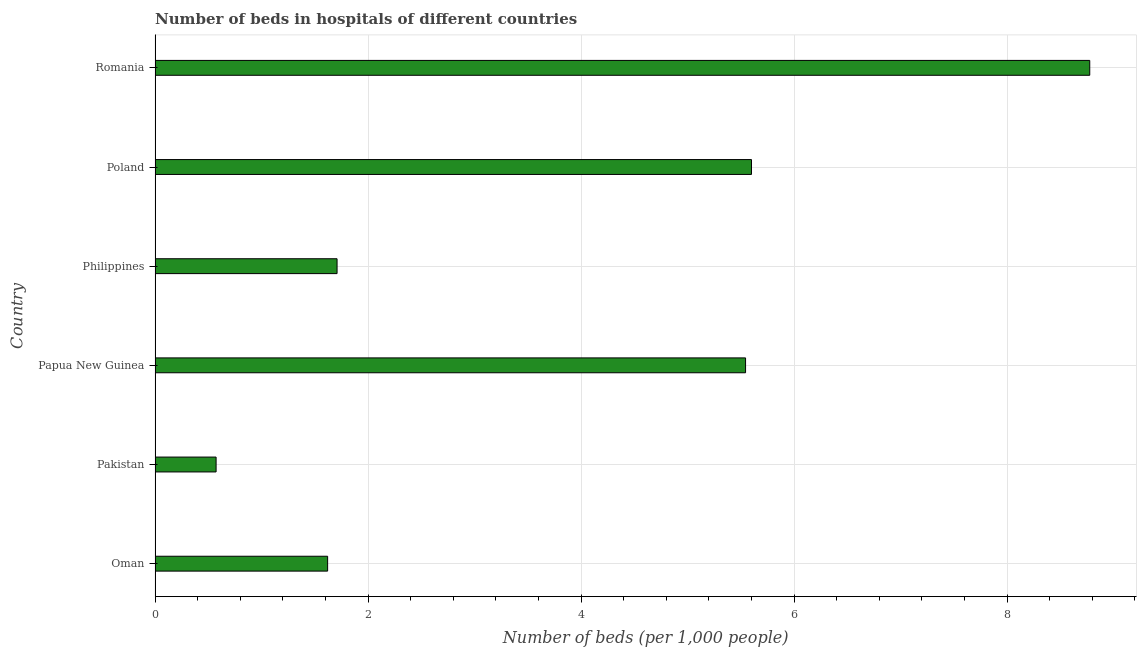Does the graph contain any zero values?
Provide a short and direct response. No. What is the title of the graph?
Provide a succinct answer. Number of beds in hospitals of different countries. What is the label or title of the X-axis?
Keep it short and to the point. Number of beds (per 1,0 people). What is the number of hospital beds in Pakistan?
Provide a succinct answer. 0.57. Across all countries, what is the maximum number of hospital beds?
Your answer should be compact. 8.78. Across all countries, what is the minimum number of hospital beds?
Offer a terse response. 0.57. In which country was the number of hospital beds maximum?
Provide a succinct answer. Romania. What is the sum of the number of hospital beds?
Provide a short and direct response. 23.82. What is the difference between the number of hospital beds in Pakistan and Philippines?
Keep it short and to the point. -1.14. What is the average number of hospital beds per country?
Offer a very short reply. 3.97. What is the median number of hospital beds?
Your response must be concise. 3.63. What is the ratio of the number of hospital beds in Pakistan to that in Romania?
Your response must be concise. 0.07. Is the difference between the number of hospital beds in Papua New Guinea and Poland greater than the difference between any two countries?
Offer a terse response. No. What is the difference between the highest and the second highest number of hospital beds?
Provide a succinct answer. 3.18. Is the sum of the number of hospital beds in Papua New Guinea and Philippines greater than the maximum number of hospital beds across all countries?
Make the answer very short. No. How many bars are there?
Provide a short and direct response. 6. How many countries are there in the graph?
Offer a very short reply. 6. What is the difference between two consecutive major ticks on the X-axis?
Your answer should be compact. 2. What is the Number of beds (per 1,000 people) in Oman?
Provide a succinct answer. 1.62. What is the Number of beds (per 1,000 people) in Pakistan?
Your response must be concise. 0.57. What is the Number of beds (per 1,000 people) of Papua New Guinea?
Make the answer very short. 5.54. What is the Number of beds (per 1,000 people) in Philippines?
Provide a short and direct response. 1.71. What is the Number of beds (per 1,000 people) in Poland?
Give a very brief answer. 5.6. What is the Number of beds (per 1,000 people) in Romania?
Keep it short and to the point. 8.78. What is the difference between the Number of beds (per 1,000 people) in Oman and Pakistan?
Your response must be concise. 1.05. What is the difference between the Number of beds (per 1,000 people) in Oman and Papua New Guinea?
Give a very brief answer. -3.92. What is the difference between the Number of beds (per 1,000 people) in Oman and Philippines?
Ensure brevity in your answer.  -0.09. What is the difference between the Number of beds (per 1,000 people) in Oman and Poland?
Provide a succinct answer. -3.98. What is the difference between the Number of beds (per 1,000 people) in Oman and Romania?
Offer a very short reply. -7.16. What is the difference between the Number of beds (per 1,000 people) in Pakistan and Papua New Guinea?
Provide a succinct answer. -4.97. What is the difference between the Number of beds (per 1,000 people) in Pakistan and Philippines?
Provide a succinct answer. -1.14. What is the difference between the Number of beds (per 1,000 people) in Pakistan and Poland?
Give a very brief answer. -5.03. What is the difference between the Number of beds (per 1,000 people) in Pakistan and Romania?
Your answer should be very brief. -8.2. What is the difference between the Number of beds (per 1,000 people) in Papua New Guinea and Philippines?
Keep it short and to the point. 3.84. What is the difference between the Number of beds (per 1,000 people) in Papua New Guinea and Poland?
Keep it short and to the point. -0.06. What is the difference between the Number of beds (per 1,000 people) in Papua New Guinea and Romania?
Give a very brief answer. -3.23. What is the difference between the Number of beds (per 1,000 people) in Philippines and Poland?
Keep it short and to the point. -3.89. What is the difference between the Number of beds (per 1,000 people) in Philippines and Romania?
Your answer should be compact. -7.07. What is the difference between the Number of beds (per 1,000 people) in Poland and Romania?
Ensure brevity in your answer.  -3.18. What is the ratio of the Number of beds (per 1,000 people) in Oman to that in Pakistan?
Provide a short and direct response. 2.83. What is the ratio of the Number of beds (per 1,000 people) in Oman to that in Papua New Guinea?
Offer a very short reply. 0.29. What is the ratio of the Number of beds (per 1,000 people) in Oman to that in Philippines?
Your answer should be very brief. 0.95. What is the ratio of the Number of beds (per 1,000 people) in Oman to that in Poland?
Your answer should be very brief. 0.29. What is the ratio of the Number of beds (per 1,000 people) in Oman to that in Romania?
Your answer should be very brief. 0.18. What is the ratio of the Number of beds (per 1,000 people) in Pakistan to that in Papua New Guinea?
Provide a succinct answer. 0.1. What is the ratio of the Number of beds (per 1,000 people) in Pakistan to that in Philippines?
Offer a terse response. 0.34. What is the ratio of the Number of beds (per 1,000 people) in Pakistan to that in Poland?
Keep it short and to the point. 0.1. What is the ratio of the Number of beds (per 1,000 people) in Pakistan to that in Romania?
Give a very brief answer. 0.07. What is the ratio of the Number of beds (per 1,000 people) in Papua New Guinea to that in Philippines?
Your answer should be very brief. 3.24. What is the ratio of the Number of beds (per 1,000 people) in Papua New Guinea to that in Poland?
Your response must be concise. 0.99. What is the ratio of the Number of beds (per 1,000 people) in Papua New Guinea to that in Romania?
Provide a short and direct response. 0.63. What is the ratio of the Number of beds (per 1,000 people) in Philippines to that in Poland?
Offer a terse response. 0.3. What is the ratio of the Number of beds (per 1,000 people) in Philippines to that in Romania?
Your response must be concise. 0.2. What is the ratio of the Number of beds (per 1,000 people) in Poland to that in Romania?
Your answer should be very brief. 0.64. 